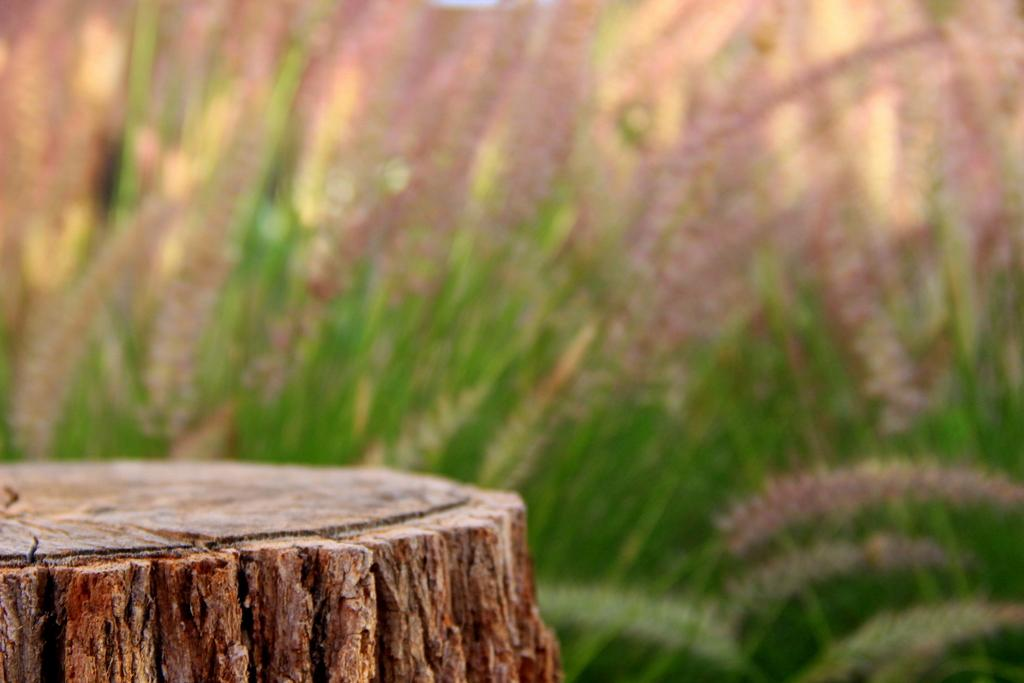What material is present in the image? There is wood in the image. What type of vegetation can be seen in the background of the image? There are blurred plants in the background of the image. What is the acoustics rating of the lunchroom in the image? There is no lunchroom present in the image, so it is not possible to determine the acoustics rating. 